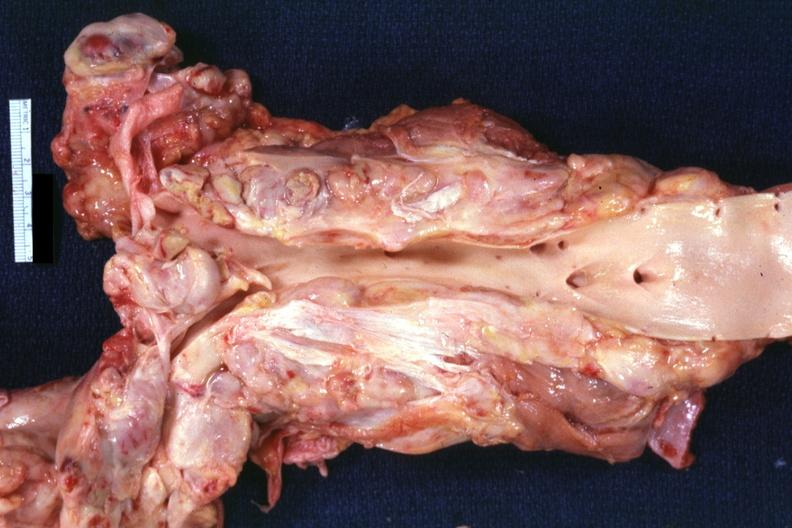does this image show opened aorta surrounded by enlarge nodes?
Answer the question using a single word or phrase. Yes 